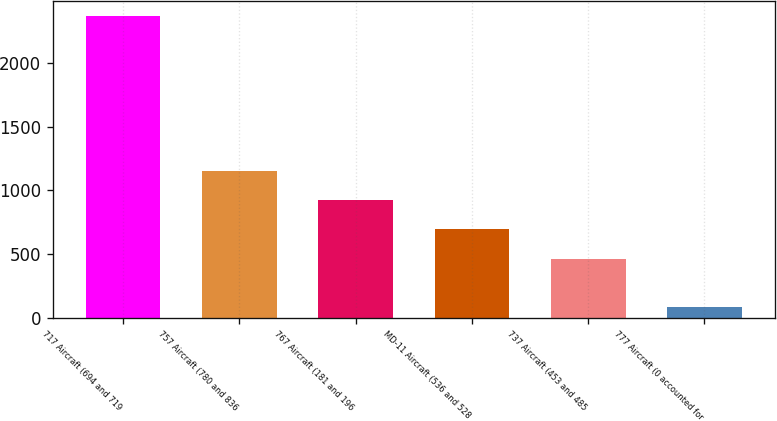Convert chart to OTSL. <chart><loc_0><loc_0><loc_500><loc_500><bar_chart><fcel>717 Aircraft (694 and 719<fcel>757 Aircraft (780 and 836<fcel>767 Aircraft (181 and 196<fcel>MD-11 Aircraft (536 and 528<fcel>737 Aircraft (453 and 485<fcel>777 Aircraft (0 accounted for<nl><fcel>2365<fcel>1149.2<fcel>920.8<fcel>692.4<fcel>464<fcel>81<nl></chart> 